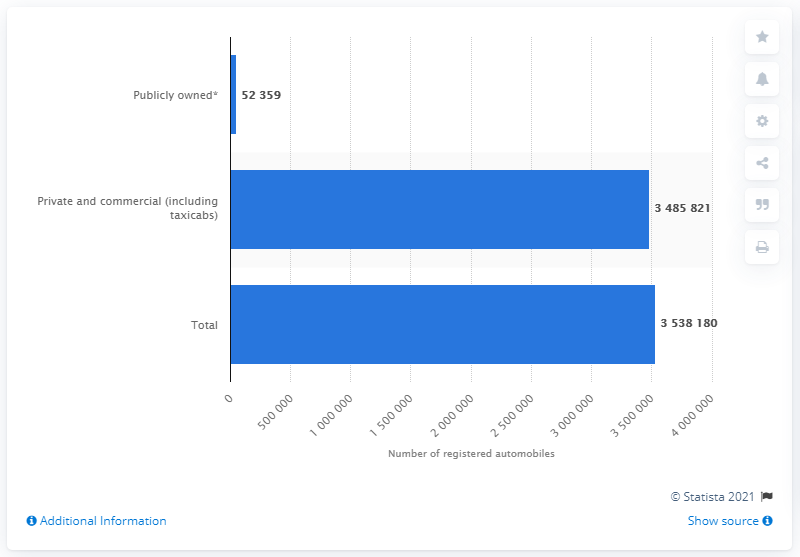Identify some key points in this picture. In 2016, a total of 348,5821 private and commercial automobiles were registered in the state of Georgia. 